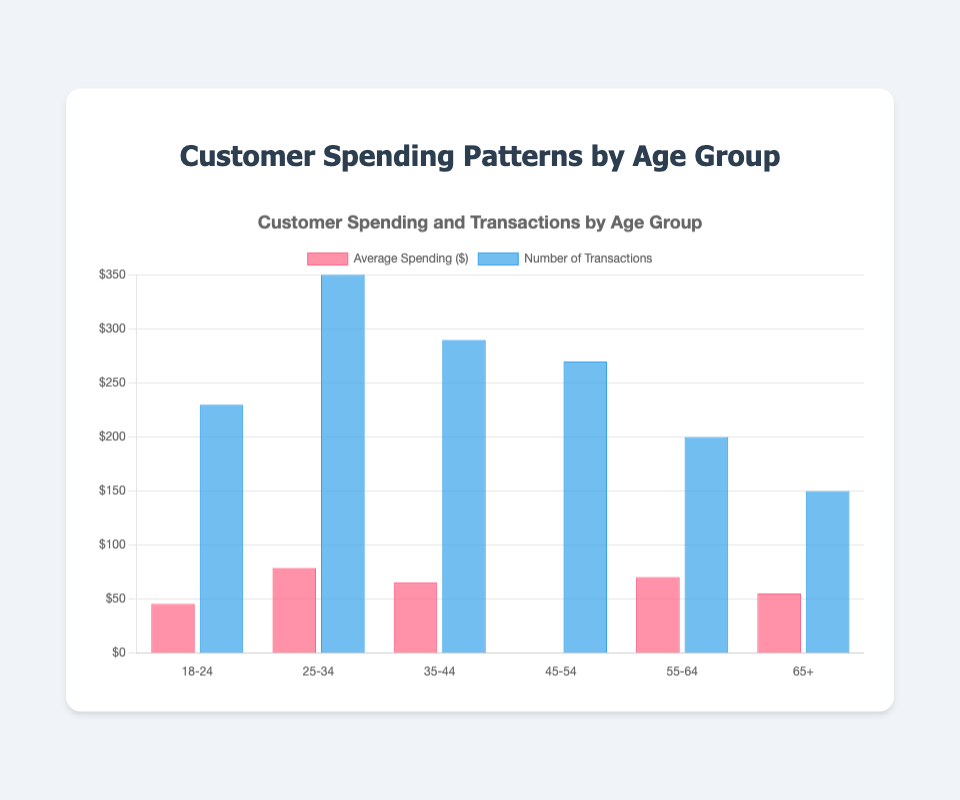What is the average spending for the 25-34 age group? The average spending for the 25-34 age group is directly listed in the data.
Answer: $78.90 How many transactions were made by the 35-44 age group? The figure indicates the number of transactions for each age group. Look for the transactions value listed for the 35-44 age group.
Answer: 290 Which age group has the highest average spending? By comparing the average_spending values for all age groups, the highest value is the average spending of the 45-54 age group.
Answer: 45-54 Which age group had the least number of transactions? By looking at the transactions for each age group, the 65+ age group has the smallest number.
Answer: 65+ What is the combined number of transactions for the 18-24 and 25-34 age groups? Adding the transactions for the 18-24 (230) and 25-34 (350) age groups: 230 + 350 = 580.
Answer: 580 How does the average spending of the 55-64 age group compare to the 65+ age group? The average spending is $70.45 for the 55-64 age group and $55.25 for the 65+ age group. So, the 55-64 group spends more.
Answer: 55-64 spends more What is the total number of transactions across all age groups? Adding the `transactions` values for all groups: 230 + 350 + 290 + 270 + 200 + 150 = 1490.
Answer: 1490 What's the difference in average spending between the 45-54 and 18-24 age groups? Subtract the average spending of the 18-24 group from that of the 45-54 group: 82.10 - 45.60 = 36.50.
Answer: $36.50 Between which age groups is the difference in average spending the smallest? Calculating the difference in average spending between all adjacent age groups: 25-34 to 35-44 (78.90 - 65.30 = 13.60), 35-44 to 45-54 (82.10 - 65.30 = 16.80), etc. The smallest difference is between the 65+ and 18-24 groups.
Answer: 18-24 and 65+ 